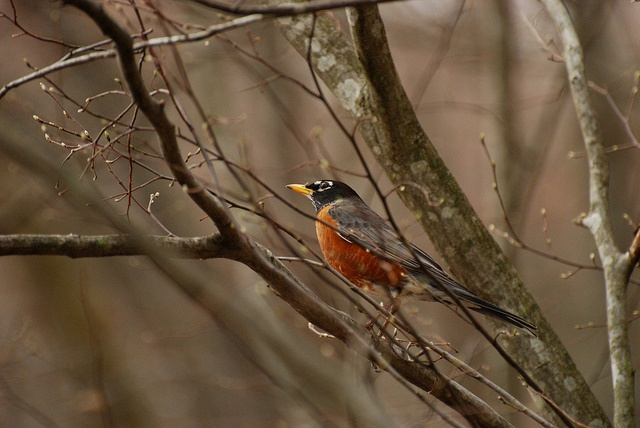Describe the objects in this image and their specific colors. I can see a bird in gray, maroon, and black tones in this image. 